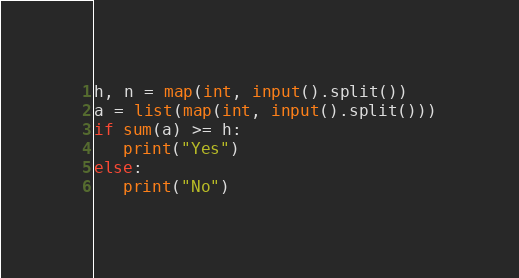<code> <loc_0><loc_0><loc_500><loc_500><_Python_>h, n = map(int, input().split())
a = list(map(int, input().split()))
if sum(a) >= h:
   print("Yes")
else:
   print("No")
</code> 